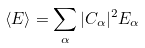<formula> <loc_0><loc_0><loc_500><loc_500>\langle E \rangle = \sum _ { \alpha } | C _ { \alpha } | ^ { 2 } E _ { \alpha }</formula> 